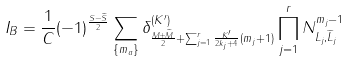<formula> <loc_0><loc_0><loc_500><loc_500>I _ { B } = \frac { 1 } { C } ( - 1 ) ^ { \frac { S - \widetilde { S } } { 2 } } \sum _ { \{ m _ { a } \} } \delta _ { \frac { M + \widetilde { M } } { 2 } + \sum _ { j = 1 } ^ { r } \frac { K ^ { \prime } } { 2 k _ { j } + 4 } ( m _ { j } + 1 ) } ^ { ( K ^ { \prime } ) } \prod _ { j = 1 } ^ { r } N _ { L _ { j } , \widetilde { L } _ { j } } ^ { m _ { j } - 1 }</formula> 